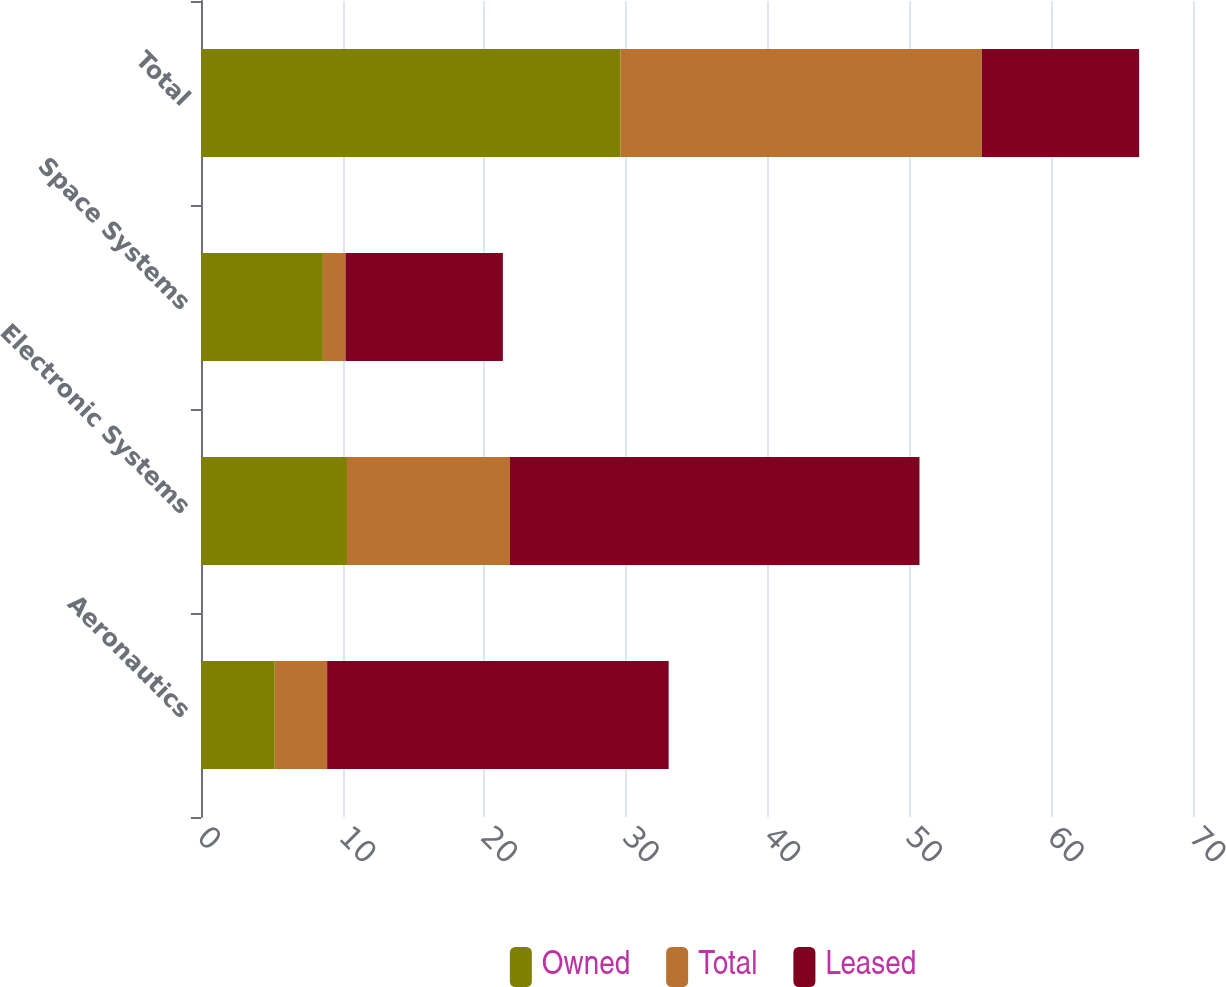Convert chart to OTSL. <chart><loc_0><loc_0><loc_500><loc_500><stacked_bar_chart><ecel><fcel>Aeronautics<fcel>Electronic Systems<fcel>Space Systems<fcel>Total<nl><fcel>Owned<fcel>5.2<fcel>10.3<fcel>8.6<fcel>29.6<nl><fcel>Total<fcel>3.7<fcel>11.5<fcel>1.6<fcel>25.5<nl><fcel>Leased<fcel>24.1<fcel>28.9<fcel>11.1<fcel>11.1<nl></chart> 